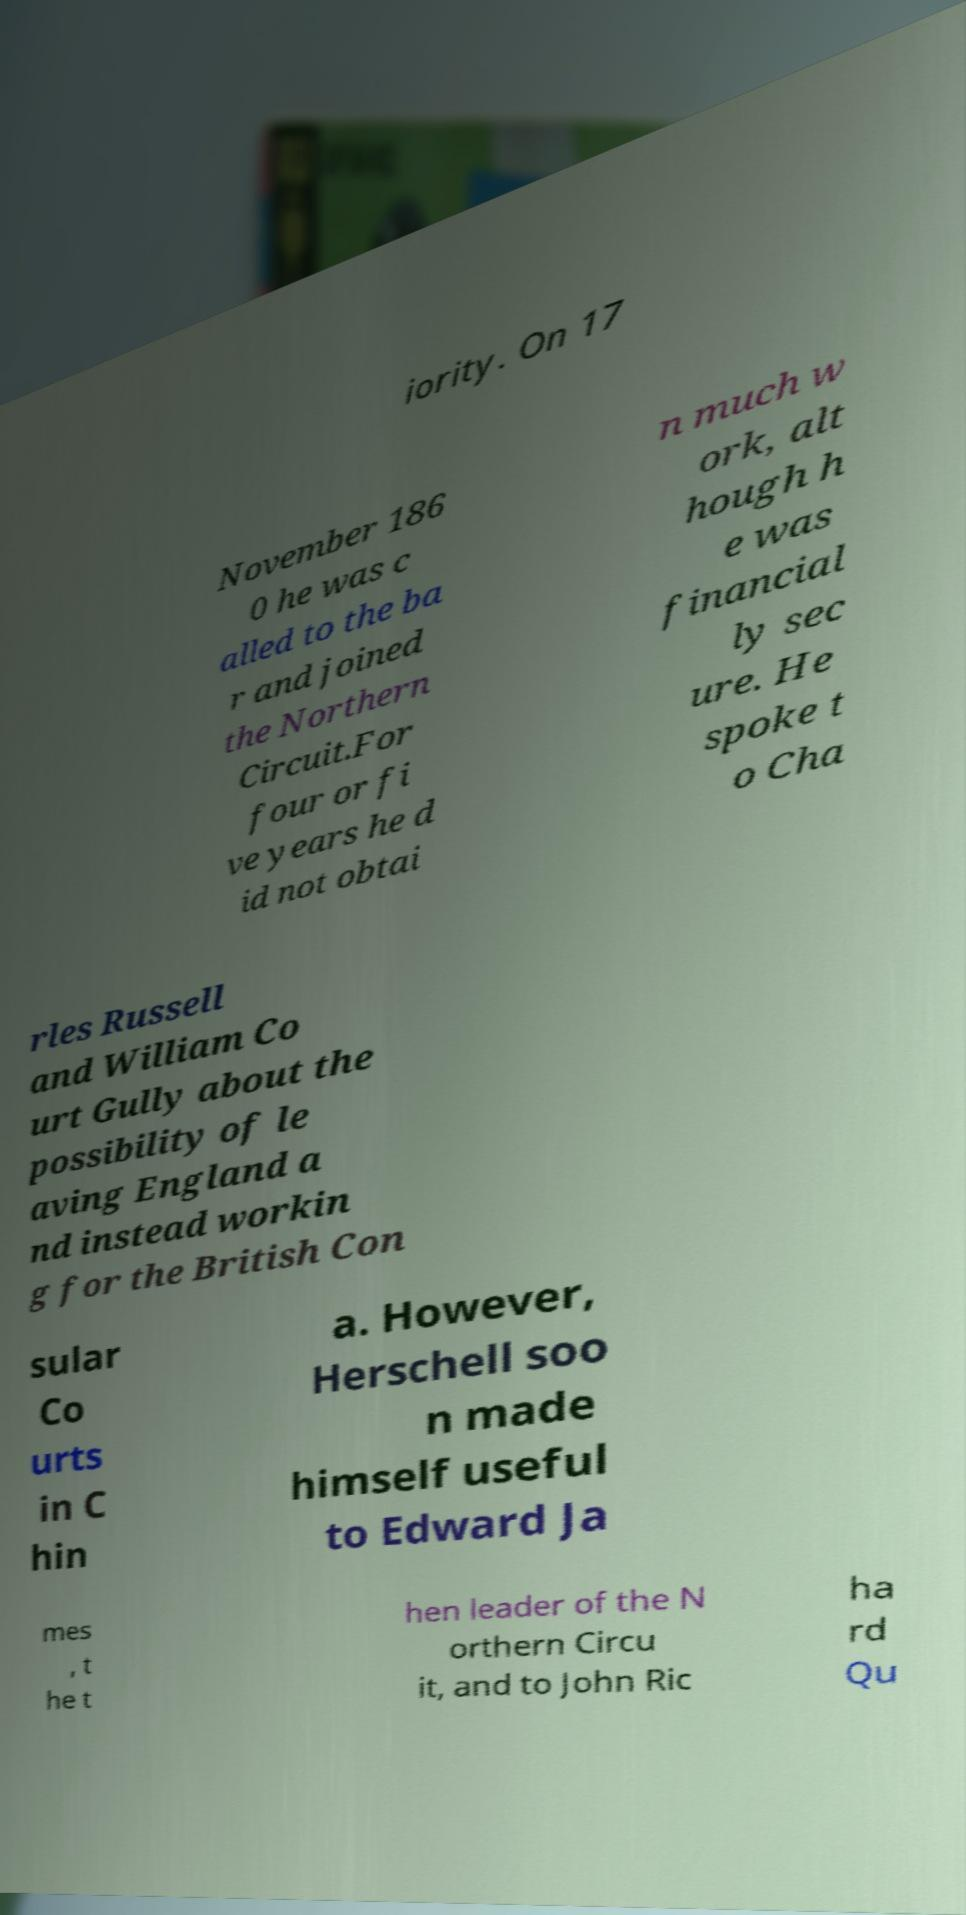Please read and relay the text visible in this image. What does it say? iority. On 17 November 186 0 he was c alled to the ba r and joined the Northern Circuit.For four or fi ve years he d id not obtai n much w ork, alt hough h e was financial ly sec ure. He spoke t o Cha rles Russell and William Co urt Gully about the possibility of le aving England a nd instead workin g for the British Con sular Co urts in C hin a. However, Herschell soo n made himself useful to Edward Ja mes , t he t hen leader of the N orthern Circu it, and to John Ric ha rd Qu 